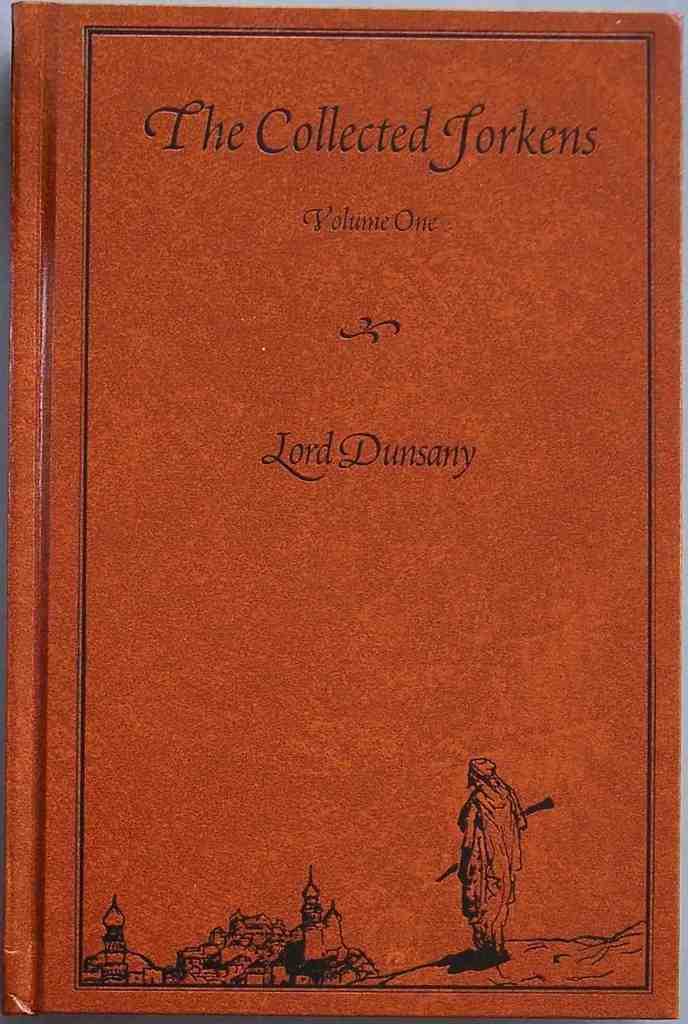What is the name of the book?
Give a very brief answer. The collected jorkens. 